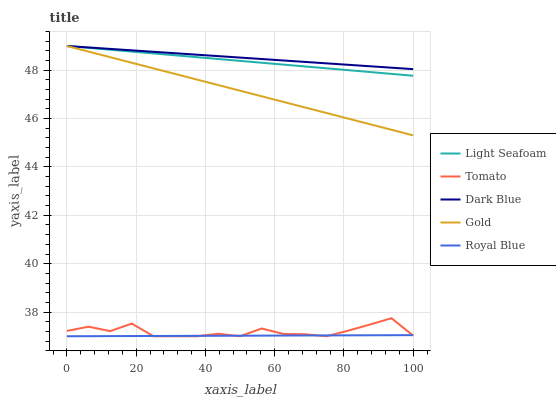Does Royal Blue have the minimum area under the curve?
Answer yes or no. Yes. Does Dark Blue have the maximum area under the curve?
Answer yes or no. Yes. Does Light Seafoam have the minimum area under the curve?
Answer yes or no. No. Does Light Seafoam have the maximum area under the curve?
Answer yes or no. No. Is Dark Blue the smoothest?
Answer yes or no. Yes. Is Tomato the roughest?
Answer yes or no. Yes. Is Light Seafoam the smoothest?
Answer yes or no. No. Is Light Seafoam the roughest?
Answer yes or no. No. Does Tomato have the lowest value?
Answer yes or no. Yes. Does Light Seafoam have the lowest value?
Answer yes or no. No. Does Gold have the highest value?
Answer yes or no. Yes. Does Royal Blue have the highest value?
Answer yes or no. No. Is Royal Blue less than Light Seafoam?
Answer yes or no. Yes. Is Dark Blue greater than Tomato?
Answer yes or no. Yes. Does Light Seafoam intersect Dark Blue?
Answer yes or no. Yes. Is Light Seafoam less than Dark Blue?
Answer yes or no. No. Is Light Seafoam greater than Dark Blue?
Answer yes or no. No. Does Royal Blue intersect Light Seafoam?
Answer yes or no. No. 